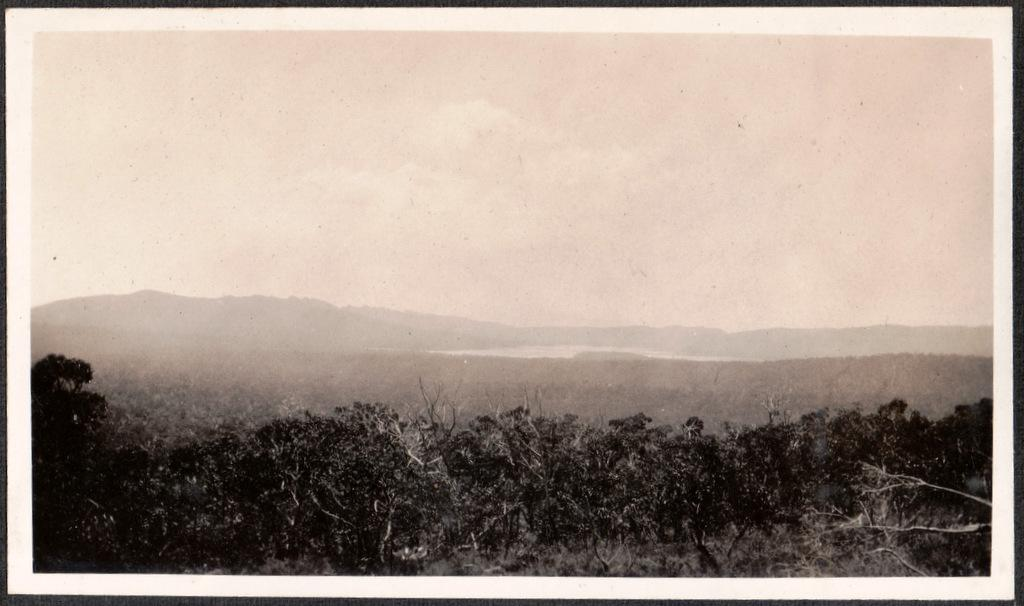What is the main subject of the image? The image contains a photograph. What type of natural elements can be seen at the bottom side of the image? There are trees at the bottom side of the image. What part of the sky is visible in the image? There is sky at the top side of the image. How many tickets can be seen hanging from the trees in the image? There are no tickets present in the image; it features a photograph with trees and sky. What type of blade is being used to cut the neck of the person in the image? There is no person or blade present in the image; it only contains a photograph with trees and sky. 